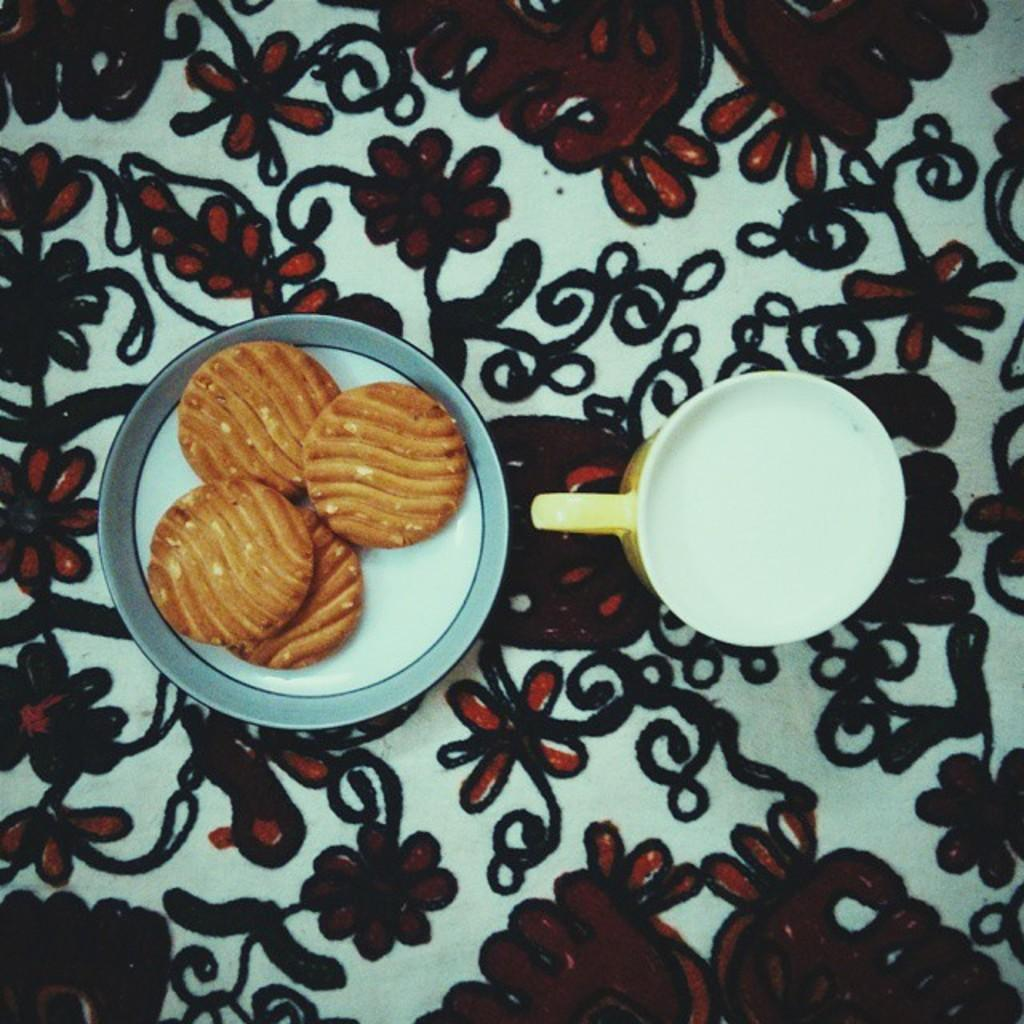What type of designs can be seen in the image? There are designs of flowers in the image. What is the primary object in the image? There is a cup in the image. What type of food is present in the image? There are biscuits in a bowl in the image. What type of tin can be seen in the image? There is no tin present in the image. How many beds are visible in the image? There are no beds visible in the image. 